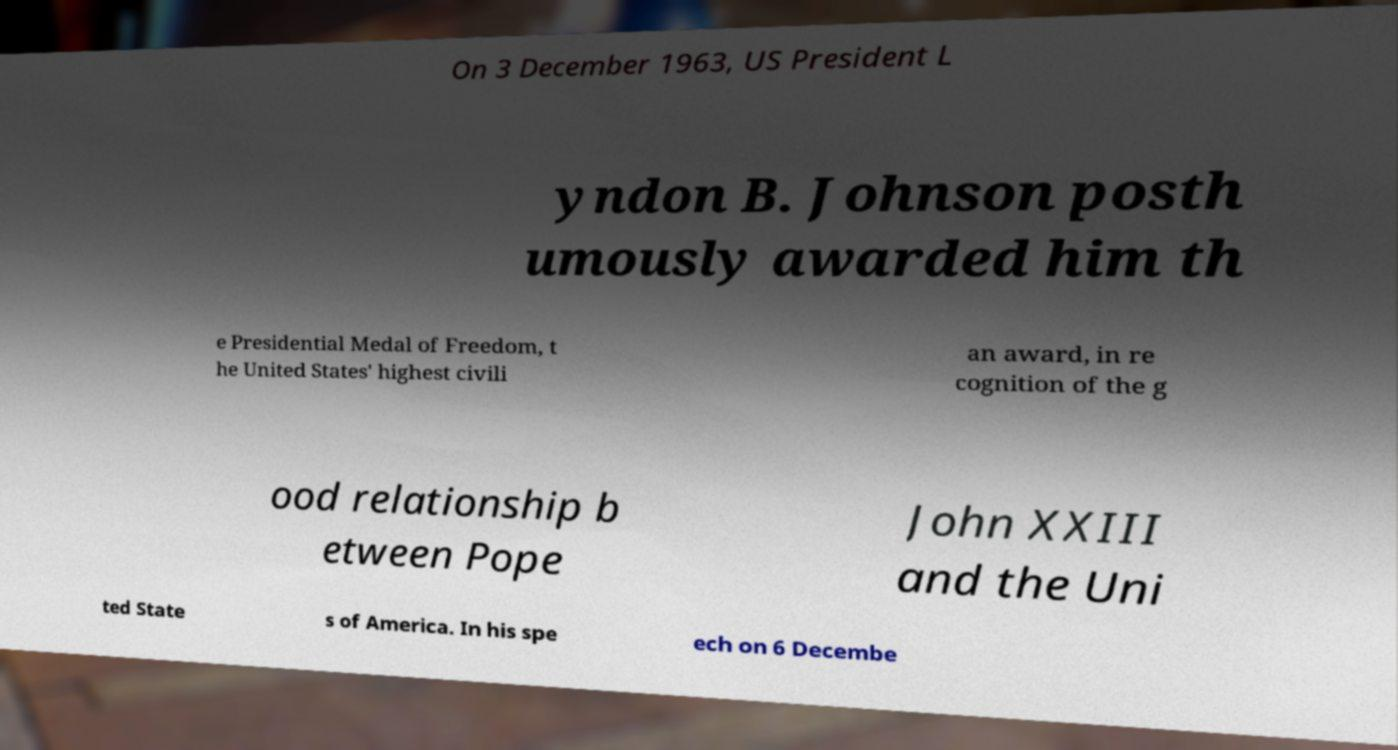There's text embedded in this image that I need extracted. Can you transcribe it verbatim? On 3 December 1963, US President L yndon B. Johnson posth umously awarded him th e Presidential Medal of Freedom, t he United States' highest civili an award, in re cognition of the g ood relationship b etween Pope John XXIII and the Uni ted State s of America. In his spe ech on 6 Decembe 